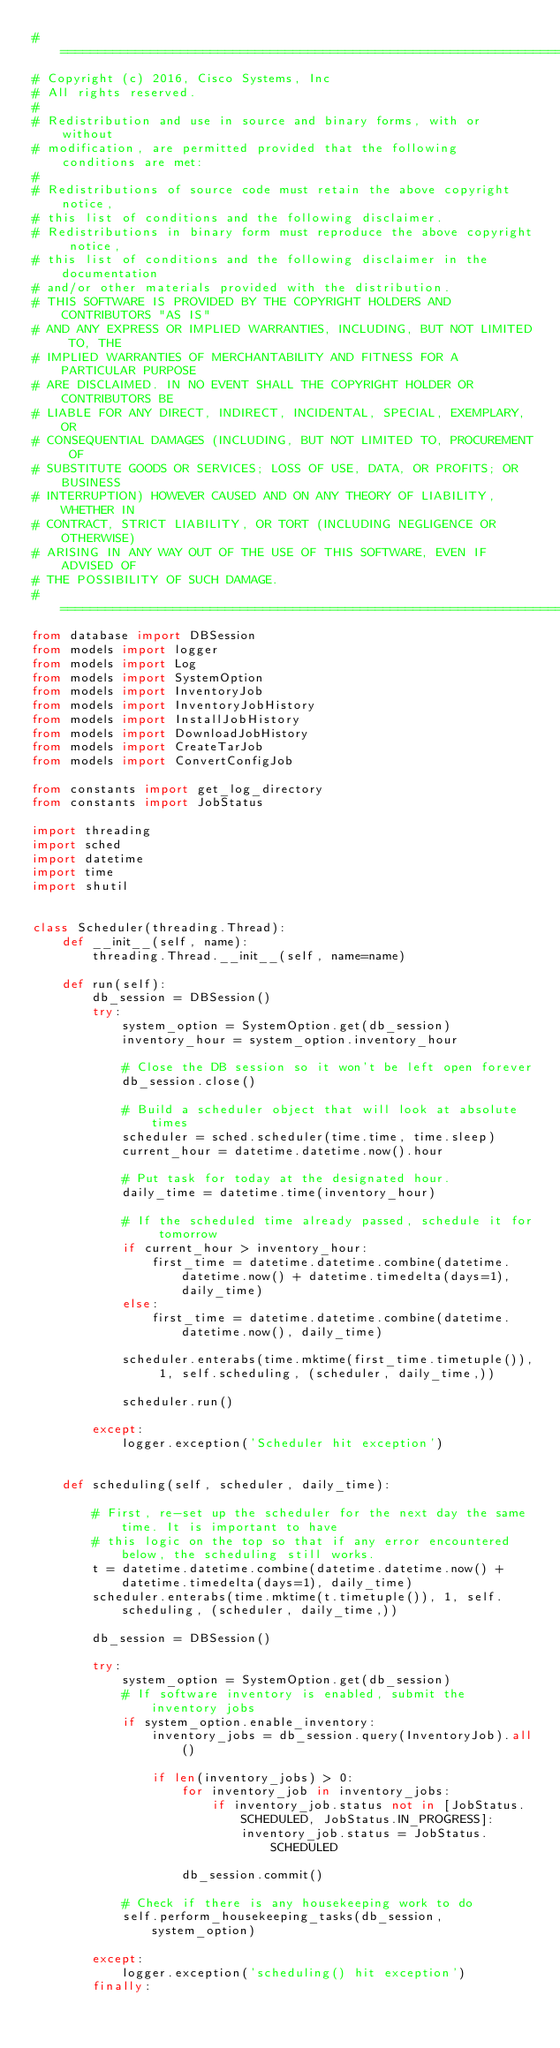Convert code to text. <code><loc_0><loc_0><loc_500><loc_500><_Python_># =============================================================================
# Copyright (c) 2016, Cisco Systems, Inc
# All rights reserved.
#
# Redistribution and use in source and binary forms, with or without
# modification, are permitted provided that the following conditions are met:
#
# Redistributions of source code must retain the above copyright notice,
# this list of conditions and the following disclaimer.
# Redistributions in binary form must reproduce the above copyright notice,
# this list of conditions and the following disclaimer in the documentation
# and/or other materials provided with the distribution.
# THIS SOFTWARE IS PROVIDED BY THE COPYRIGHT HOLDERS AND CONTRIBUTORS "AS IS"
# AND ANY EXPRESS OR IMPLIED WARRANTIES, INCLUDING, BUT NOT LIMITED TO, THE
# IMPLIED WARRANTIES OF MERCHANTABILITY AND FITNESS FOR A PARTICULAR PURPOSE
# ARE DISCLAIMED. IN NO EVENT SHALL THE COPYRIGHT HOLDER OR CONTRIBUTORS BE
# LIABLE FOR ANY DIRECT, INDIRECT, INCIDENTAL, SPECIAL, EXEMPLARY, OR
# CONSEQUENTIAL DAMAGES (INCLUDING, BUT NOT LIMITED TO, PROCUREMENT OF
# SUBSTITUTE GOODS OR SERVICES; LOSS OF USE, DATA, OR PROFITS; OR BUSINESS
# INTERRUPTION) HOWEVER CAUSED AND ON ANY THEORY OF LIABILITY, WHETHER IN
# CONTRACT, STRICT LIABILITY, OR TORT (INCLUDING NEGLIGENCE OR OTHERWISE)
# ARISING IN ANY WAY OUT OF THE USE OF THIS SOFTWARE, EVEN IF ADVISED OF
# THE POSSIBILITY OF SUCH DAMAGE.
# =============================================================================
from database import DBSession
from models import logger
from models import Log
from models import SystemOption
from models import InventoryJob
from models import InventoryJobHistory
from models import InstallJobHistory
from models import DownloadJobHistory
from models import CreateTarJob
from models import ConvertConfigJob

from constants import get_log_directory
from constants import JobStatus

import threading 
import sched
import datetime
import time
import shutil


class Scheduler(threading.Thread):
    def __init__(self, name):
        threading.Thread.__init__(self, name=name)
        
    def run(self):
        db_session = DBSession()   
        try:         
            system_option = SystemOption.get(db_session)            
            inventory_hour = system_option.inventory_hour

            # Close the DB session so it won't be left open forever
            db_session.close()
                        
            # Build a scheduler object that will look at absolute times
            scheduler = sched.scheduler(time.time, time.sleep)
            current_hour = datetime.datetime.now().hour
    
            # Put task for today at the designated hour.
            daily_time = datetime.time(inventory_hour)
            
            # If the scheduled time already passed, schedule it for tomorrow
            if current_hour > inventory_hour:
                first_time = datetime.datetime.combine(datetime.datetime.now() + datetime.timedelta(days=1), daily_time)
            else:
                first_time = datetime.datetime.combine(datetime.datetime.now(), daily_time)
            
            scheduler.enterabs(time.mktime(first_time.timetuple()), 1, self.scheduling, (scheduler, daily_time,))
           
            scheduler.run()
            
        except:
            logger.exception('Scheduler hit exception')

            
    def scheduling(self, scheduler, daily_time):
        
        # First, re-set up the scheduler for the next day the same time. It is important to have
        # this logic on the top so that if any error encountered below, the scheduling still works.
        t = datetime.datetime.combine(datetime.datetime.now() + datetime.timedelta(days=1), daily_time)
        scheduler.enterabs(time.mktime(t.timetuple()), 1, self.scheduling, (scheduler, daily_time,))
            
        db_session = DBSession()
        
        try:
            system_option = SystemOption.get(db_session)
            # If software inventory is enabled, submit the inventory jobs
            if system_option.enable_inventory:
                inventory_jobs = db_session.query(InventoryJob).all()

                if len(inventory_jobs) > 0:
                    for inventory_job in inventory_jobs:
                        if inventory_job.status not in [JobStatus.SCHEDULED, JobStatus.IN_PROGRESS]:
                            inventory_job.status = JobStatus.SCHEDULED

                    db_session.commit()
                        
            # Check if there is any housekeeping work to do
            self.perform_housekeeping_tasks(db_session, system_option)
            
        except:
            logger.exception('scheduling() hit exception')
        finally:</code> 